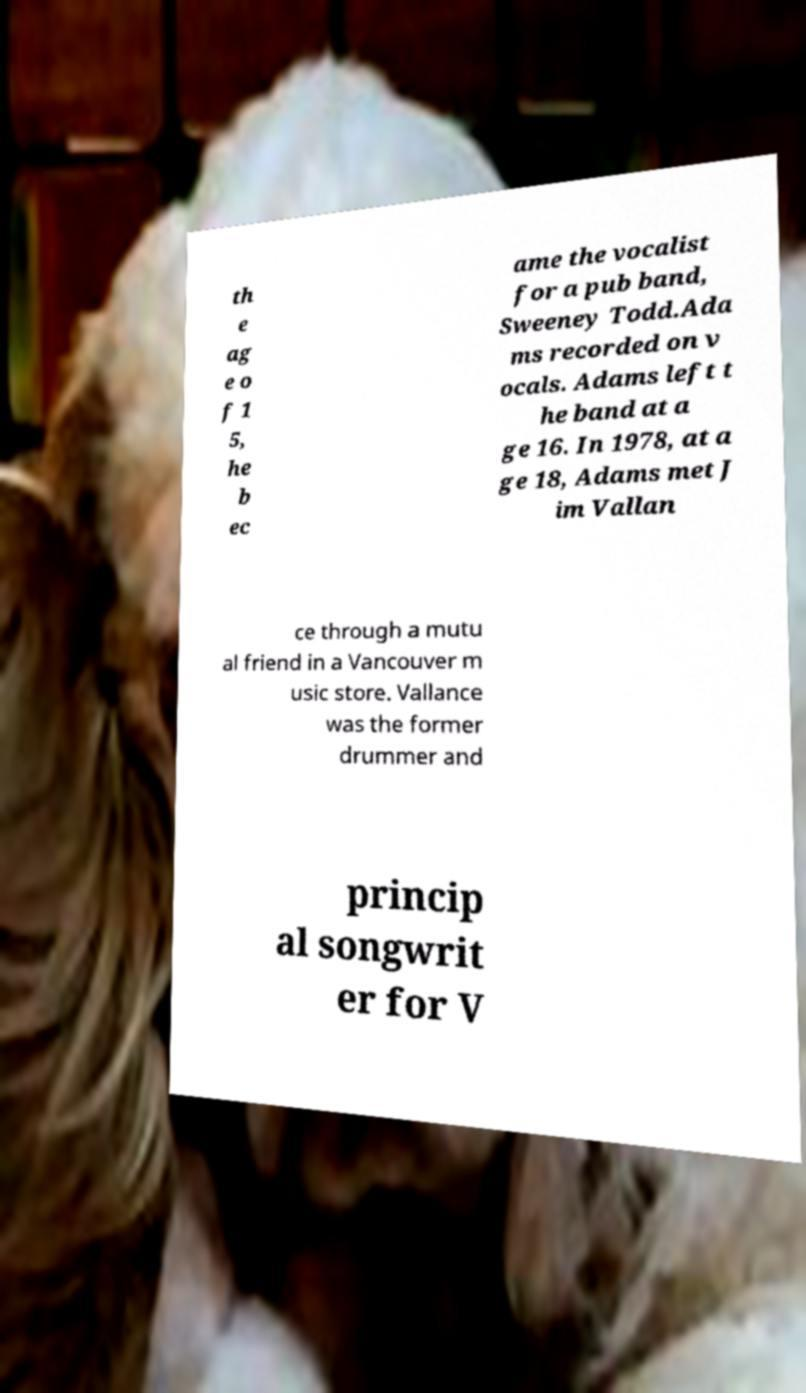Can you read and provide the text displayed in the image?This photo seems to have some interesting text. Can you extract and type it out for me? th e ag e o f 1 5, he b ec ame the vocalist for a pub band, Sweeney Todd.Ada ms recorded on v ocals. Adams left t he band at a ge 16. In 1978, at a ge 18, Adams met J im Vallan ce through a mutu al friend in a Vancouver m usic store. Vallance was the former drummer and princip al songwrit er for V 